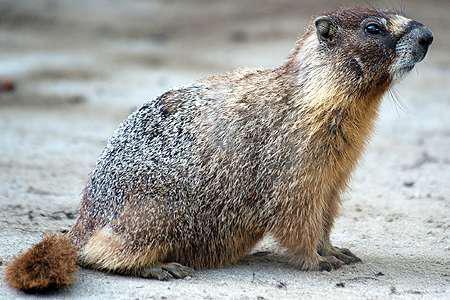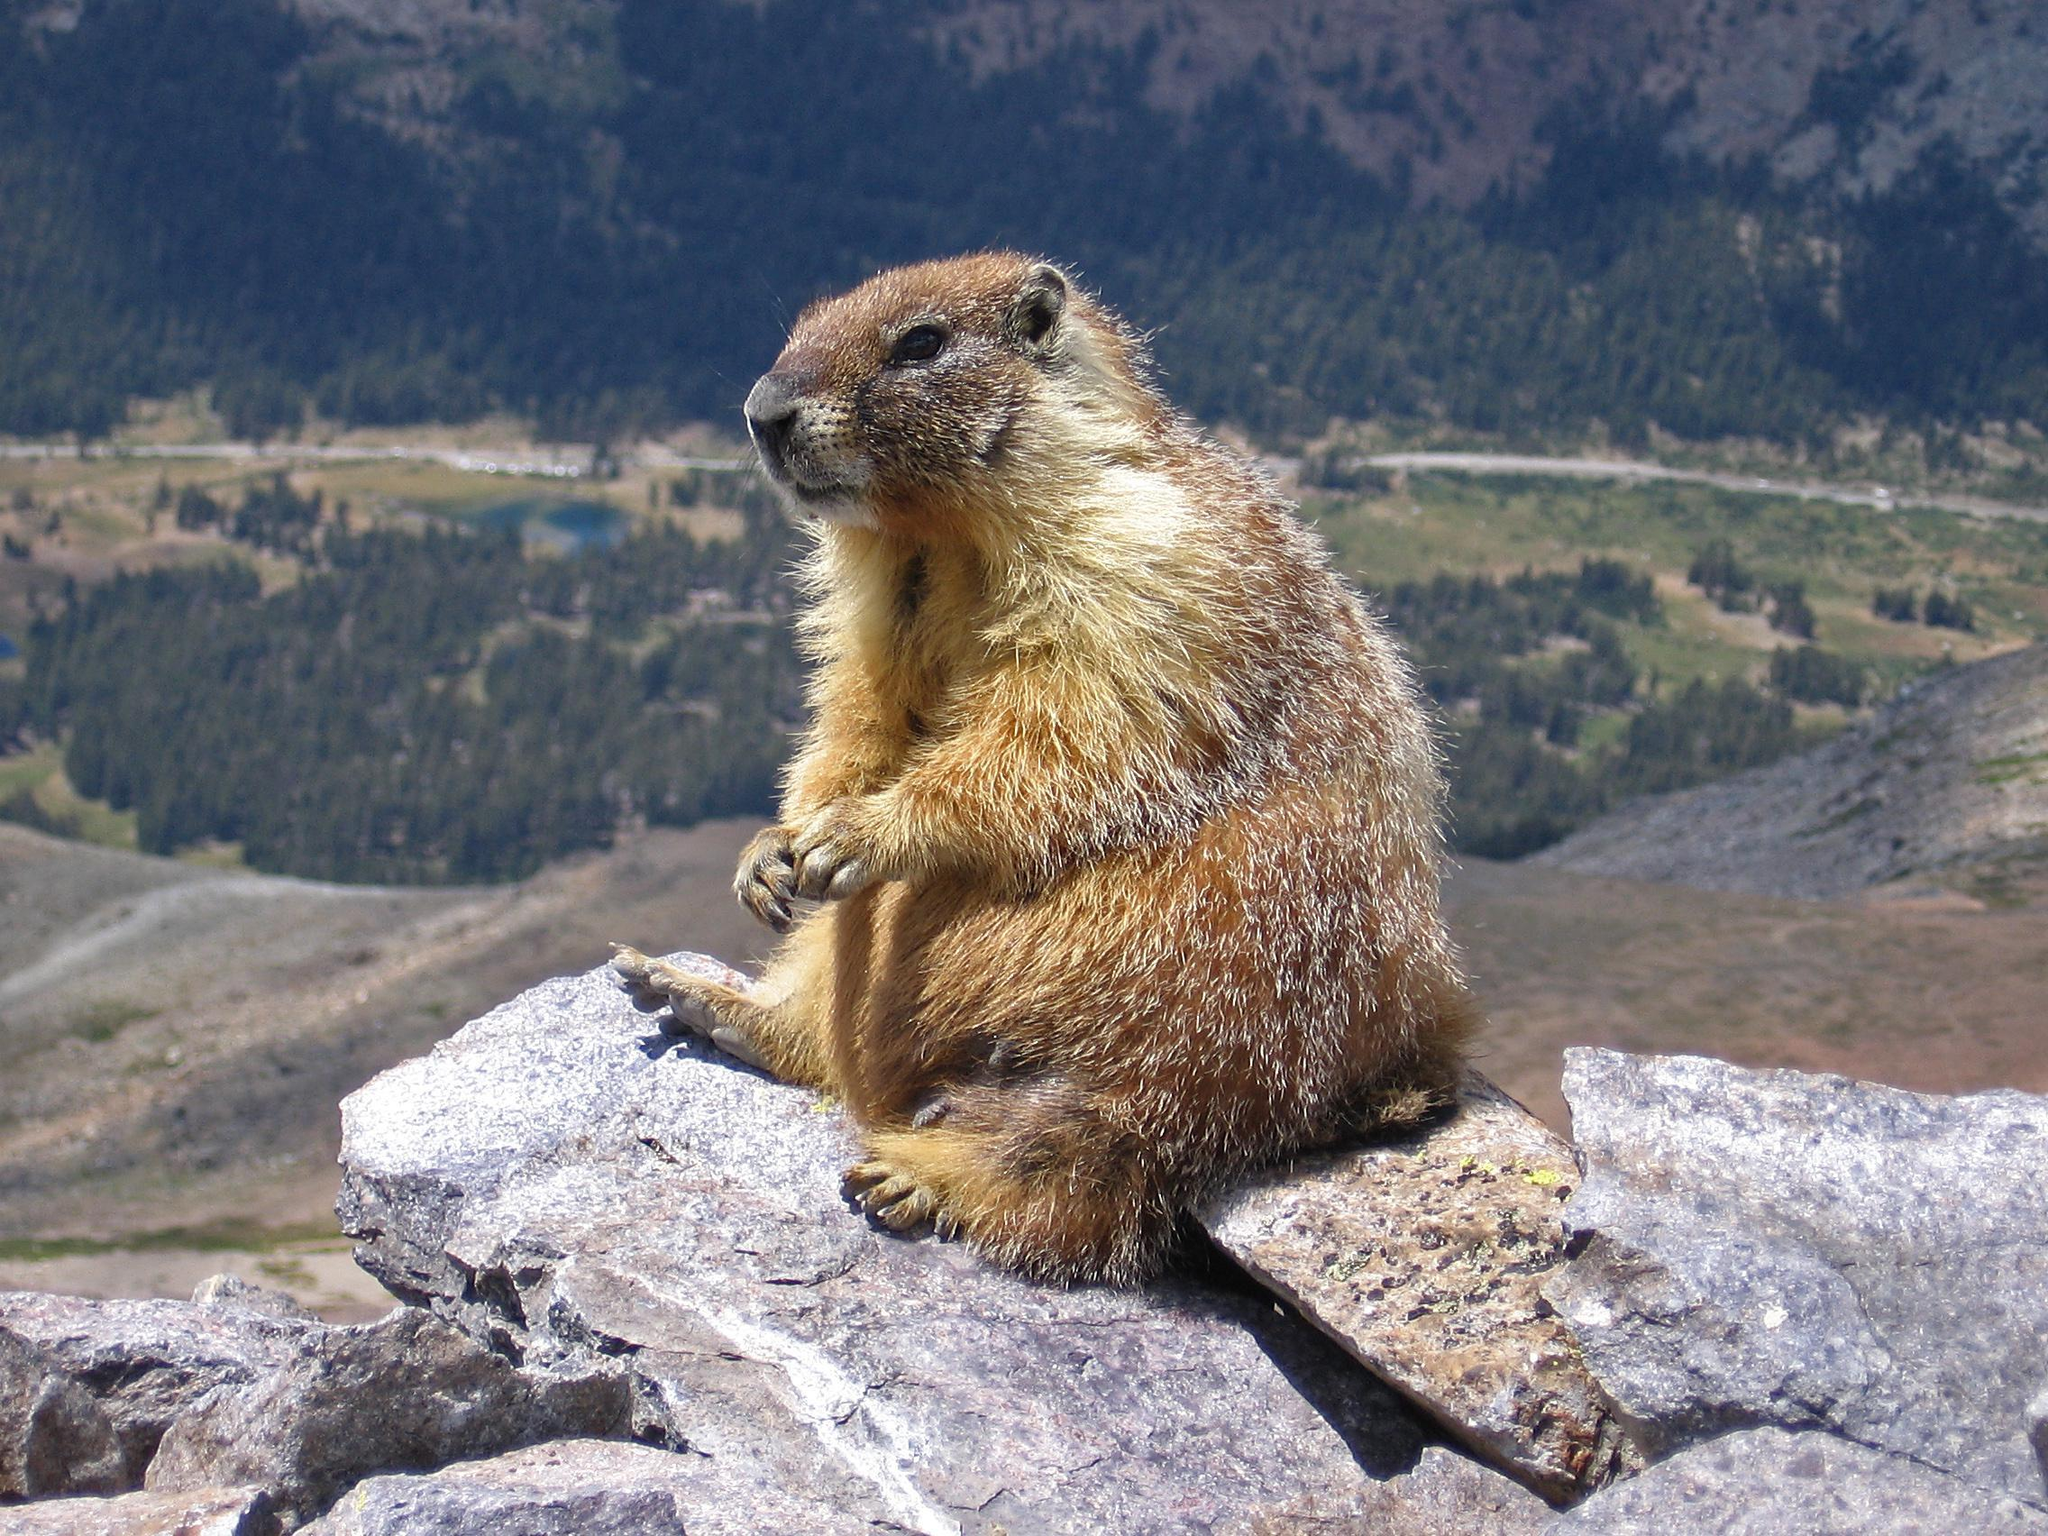The first image is the image on the left, the second image is the image on the right. For the images shown, is this caption "An image shows a marmot standing upright, with its front paws hanging downward." true? Answer yes or no. No. The first image is the image on the left, the second image is the image on the right. Assess this claim about the two images: "There is at least one ground hog with its front paws resting on a rock.". Correct or not? Answer yes or no. No. The first image is the image on the left, the second image is the image on the right. Analyze the images presented: Is the assertion "There are three animals near the rocks." valid? Answer yes or no. No. 